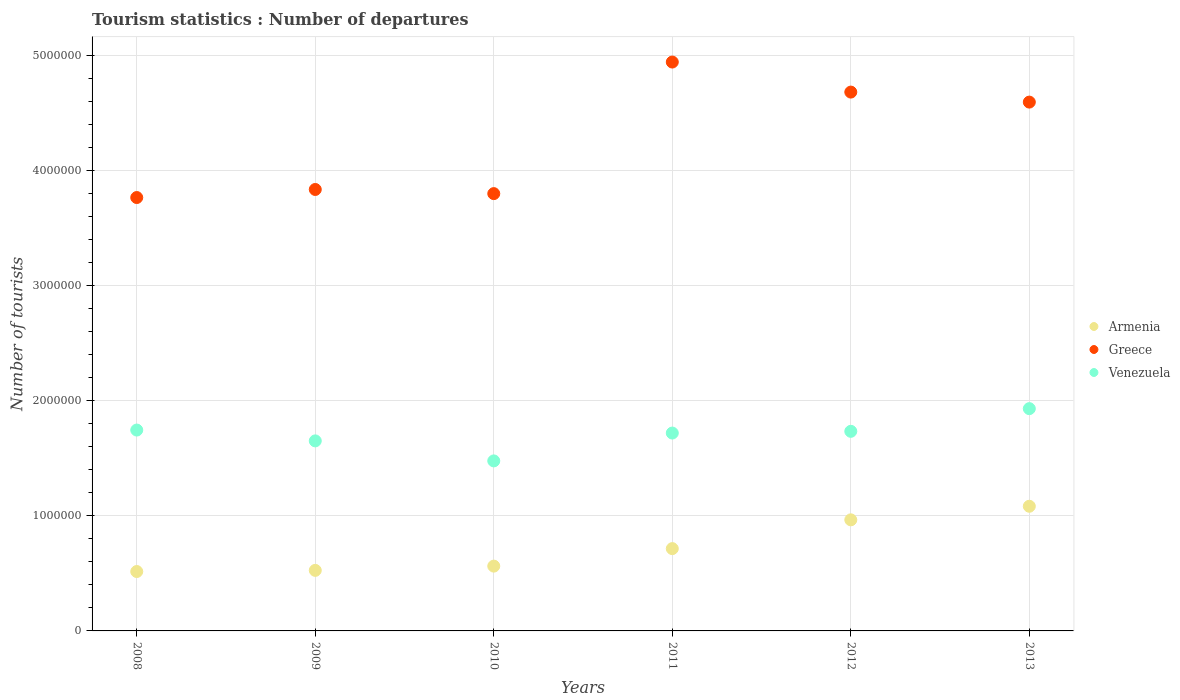How many different coloured dotlines are there?
Provide a short and direct response. 3. Is the number of dotlines equal to the number of legend labels?
Offer a terse response. Yes. What is the number of tourist departures in Armenia in 2011?
Provide a succinct answer. 7.15e+05. Across all years, what is the maximum number of tourist departures in Greece?
Give a very brief answer. 4.94e+06. Across all years, what is the minimum number of tourist departures in Armenia?
Your answer should be compact. 5.16e+05. In which year was the number of tourist departures in Armenia maximum?
Give a very brief answer. 2013. What is the total number of tourist departures in Armenia in the graph?
Your answer should be very brief. 4.37e+06. What is the difference between the number of tourist departures in Greece in 2009 and that in 2010?
Provide a succinct answer. 3.60e+04. What is the difference between the number of tourist departures in Venezuela in 2011 and the number of tourist departures in Armenia in 2009?
Your response must be concise. 1.19e+06. What is the average number of tourist departures in Greece per year?
Give a very brief answer. 4.27e+06. In the year 2010, what is the difference between the number of tourist departures in Armenia and number of tourist departures in Greece?
Offer a terse response. -3.24e+06. In how many years, is the number of tourist departures in Greece greater than 4200000?
Provide a short and direct response. 3. What is the ratio of the number of tourist departures in Venezuela in 2010 to that in 2011?
Make the answer very short. 0.86. Is the number of tourist departures in Armenia in 2012 less than that in 2013?
Ensure brevity in your answer.  Yes. What is the difference between the highest and the second highest number of tourist departures in Armenia?
Give a very brief answer. 1.18e+05. What is the difference between the highest and the lowest number of tourist departures in Venezuela?
Offer a very short reply. 4.54e+05. Is it the case that in every year, the sum of the number of tourist departures in Venezuela and number of tourist departures in Armenia  is greater than the number of tourist departures in Greece?
Offer a terse response. No. Does the graph contain any zero values?
Your answer should be very brief. No. Does the graph contain grids?
Make the answer very short. Yes. Where does the legend appear in the graph?
Provide a succinct answer. Center right. What is the title of the graph?
Offer a terse response. Tourism statistics : Number of departures. What is the label or title of the X-axis?
Your answer should be compact. Years. What is the label or title of the Y-axis?
Make the answer very short. Number of tourists. What is the Number of tourists of Armenia in 2008?
Keep it short and to the point. 5.16e+05. What is the Number of tourists of Greece in 2008?
Ensure brevity in your answer.  3.76e+06. What is the Number of tourists in Venezuela in 2008?
Offer a terse response. 1.74e+06. What is the Number of tourists of Armenia in 2009?
Make the answer very short. 5.26e+05. What is the Number of tourists of Greece in 2009?
Give a very brief answer. 3.84e+06. What is the Number of tourists of Venezuela in 2009?
Provide a succinct answer. 1.65e+06. What is the Number of tourists of Armenia in 2010?
Make the answer very short. 5.63e+05. What is the Number of tourists in Greece in 2010?
Offer a very short reply. 3.80e+06. What is the Number of tourists of Venezuela in 2010?
Offer a very short reply. 1.48e+06. What is the Number of tourists of Armenia in 2011?
Offer a very short reply. 7.15e+05. What is the Number of tourists of Greece in 2011?
Your answer should be very brief. 4.94e+06. What is the Number of tourists of Venezuela in 2011?
Your response must be concise. 1.72e+06. What is the Number of tourists of Armenia in 2012?
Provide a succinct answer. 9.65e+05. What is the Number of tourists in Greece in 2012?
Make the answer very short. 4.68e+06. What is the Number of tourists in Venezuela in 2012?
Keep it short and to the point. 1.73e+06. What is the Number of tourists of Armenia in 2013?
Ensure brevity in your answer.  1.08e+06. What is the Number of tourists of Greece in 2013?
Provide a short and direct response. 4.59e+06. What is the Number of tourists in Venezuela in 2013?
Your answer should be very brief. 1.93e+06. Across all years, what is the maximum Number of tourists of Armenia?
Give a very brief answer. 1.08e+06. Across all years, what is the maximum Number of tourists of Greece?
Your response must be concise. 4.94e+06. Across all years, what is the maximum Number of tourists in Venezuela?
Provide a succinct answer. 1.93e+06. Across all years, what is the minimum Number of tourists of Armenia?
Your answer should be compact. 5.16e+05. Across all years, what is the minimum Number of tourists in Greece?
Ensure brevity in your answer.  3.76e+06. Across all years, what is the minimum Number of tourists in Venezuela?
Keep it short and to the point. 1.48e+06. What is the total Number of tourists in Armenia in the graph?
Make the answer very short. 4.37e+06. What is the total Number of tourists in Greece in the graph?
Offer a terse response. 2.56e+07. What is the total Number of tourists in Venezuela in the graph?
Your response must be concise. 1.03e+07. What is the difference between the Number of tourists in Armenia in 2008 and that in 2009?
Offer a terse response. -10000. What is the difference between the Number of tourists of Venezuela in 2008 and that in 2009?
Your answer should be very brief. 9.40e+04. What is the difference between the Number of tourists in Armenia in 2008 and that in 2010?
Give a very brief answer. -4.70e+04. What is the difference between the Number of tourists of Greece in 2008 and that in 2010?
Offer a terse response. -3.40e+04. What is the difference between the Number of tourists in Venezuela in 2008 and that in 2010?
Ensure brevity in your answer.  2.68e+05. What is the difference between the Number of tourists in Armenia in 2008 and that in 2011?
Keep it short and to the point. -1.99e+05. What is the difference between the Number of tourists in Greece in 2008 and that in 2011?
Ensure brevity in your answer.  -1.18e+06. What is the difference between the Number of tourists of Venezuela in 2008 and that in 2011?
Keep it short and to the point. 2.60e+04. What is the difference between the Number of tourists of Armenia in 2008 and that in 2012?
Make the answer very short. -4.49e+05. What is the difference between the Number of tourists of Greece in 2008 and that in 2012?
Your answer should be very brief. -9.16e+05. What is the difference between the Number of tourists in Venezuela in 2008 and that in 2012?
Your answer should be very brief. 1.10e+04. What is the difference between the Number of tourists in Armenia in 2008 and that in 2013?
Your answer should be compact. -5.67e+05. What is the difference between the Number of tourists in Greece in 2008 and that in 2013?
Your answer should be very brief. -8.29e+05. What is the difference between the Number of tourists in Venezuela in 2008 and that in 2013?
Give a very brief answer. -1.86e+05. What is the difference between the Number of tourists in Armenia in 2009 and that in 2010?
Your answer should be compact. -3.70e+04. What is the difference between the Number of tourists in Greece in 2009 and that in 2010?
Your answer should be very brief. 3.60e+04. What is the difference between the Number of tourists of Venezuela in 2009 and that in 2010?
Provide a succinct answer. 1.74e+05. What is the difference between the Number of tourists of Armenia in 2009 and that in 2011?
Make the answer very short. -1.89e+05. What is the difference between the Number of tourists of Greece in 2009 and that in 2011?
Your answer should be very brief. -1.11e+06. What is the difference between the Number of tourists of Venezuela in 2009 and that in 2011?
Give a very brief answer. -6.80e+04. What is the difference between the Number of tourists of Armenia in 2009 and that in 2012?
Your response must be concise. -4.39e+05. What is the difference between the Number of tourists of Greece in 2009 and that in 2012?
Your answer should be compact. -8.46e+05. What is the difference between the Number of tourists of Venezuela in 2009 and that in 2012?
Make the answer very short. -8.30e+04. What is the difference between the Number of tourists of Armenia in 2009 and that in 2013?
Provide a short and direct response. -5.57e+05. What is the difference between the Number of tourists in Greece in 2009 and that in 2013?
Your answer should be very brief. -7.59e+05. What is the difference between the Number of tourists in Venezuela in 2009 and that in 2013?
Provide a short and direct response. -2.80e+05. What is the difference between the Number of tourists of Armenia in 2010 and that in 2011?
Provide a short and direct response. -1.52e+05. What is the difference between the Number of tourists of Greece in 2010 and that in 2011?
Make the answer very short. -1.14e+06. What is the difference between the Number of tourists of Venezuela in 2010 and that in 2011?
Provide a short and direct response. -2.42e+05. What is the difference between the Number of tourists in Armenia in 2010 and that in 2012?
Make the answer very short. -4.02e+05. What is the difference between the Number of tourists of Greece in 2010 and that in 2012?
Your answer should be very brief. -8.82e+05. What is the difference between the Number of tourists of Venezuela in 2010 and that in 2012?
Provide a succinct answer. -2.57e+05. What is the difference between the Number of tourists in Armenia in 2010 and that in 2013?
Provide a short and direct response. -5.20e+05. What is the difference between the Number of tourists in Greece in 2010 and that in 2013?
Keep it short and to the point. -7.95e+05. What is the difference between the Number of tourists of Venezuela in 2010 and that in 2013?
Provide a short and direct response. -4.54e+05. What is the difference between the Number of tourists in Greece in 2011 and that in 2012?
Give a very brief answer. 2.61e+05. What is the difference between the Number of tourists in Venezuela in 2011 and that in 2012?
Your answer should be compact. -1.50e+04. What is the difference between the Number of tourists in Armenia in 2011 and that in 2013?
Provide a succinct answer. -3.68e+05. What is the difference between the Number of tourists in Greece in 2011 and that in 2013?
Your answer should be compact. 3.48e+05. What is the difference between the Number of tourists of Venezuela in 2011 and that in 2013?
Your answer should be very brief. -2.12e+05. What is the difference between the Number of tourists of Armenia in 2012 and that in 2013?
Offer a terse response. -1.18e+05. What is the difference between the Number of tourists in Greece in 2012 and that in 2013?
Your answer should be compact. 8.70e+04. What is the difference between the Number of tourists of Venezuela in 2012 and that in 2013?
Your answer should be compact. -1.97e+05. What is the difference between the Number of tourists in Armenia in 2008 and the Number of tourists in Greece in 2009?
Your response must be concise. -3.32e+06. What is the difference between the Number of tourists in Armenia in 2008 and the Number of tourists in Venezuela in 2009?
Give a very brief answer. -1.14e+06. What is the difference between the Number of tourists of Greece in 2008 and the Number of tourists of Venezuela in 2009?
Provide a succinct answer. 2.11e+06. What is the difference between the Number of tourists in Armenia in 2008 and the Number of tourists in Greece in 2010?
Keep it short and to the point. -3.28e+06. What is the difference between the Number of tourists of Armenia in 2008 and the Number of tourists of Venezuela in 2010?
Make the answer very short. -9.61e+05. What is the difference between the Number of tourists in Greece in 2008 and the Number of tourists in Venezuela in 2010?
Your response must be concise. 2.29e+06. What is the difference between the Number of tourists in Armenia in 2008 and the Number of tourists in Greece in 2011?
Keep it short and to the point. -4.43e+06. What is the difference between the Number of tourists of Armenia in 2008 and the Number of tourists of Venezuela in 2011?
Give a very brief answer. -1.20e+06. What is the difference between the Number of tourists in Greece in 2008 and the Number of tourists in Venezuela in 2011?
Your response must be concise. 2.05e+06. What is the difference between the Number of tourists of Armenia in 2008 and the Number of tourists of Greece in 2012?
Your response must be concise. -4.16e+06. What is the difference between the Number of tourists of Armenia in 2008 and the Number of tourists of Venezuela in 2012?
Provide a short and direct response. -1.22e+06. What is the difference between the Number of tourists in Greece in 2008 and the Number of tourists in Venezuela in 2012?
Offer a very short reply. 2.03e+06. What is the difference between the Number of tourists of Armenia in 2008 and the Number of tourists of Greece in 2013?
Your answer should be very brief. -4.08e+06. What is the difference between the Number of tourists of Armenia in 2008 and the Number of tourists of Venezuela in 2013?
Your answer should be very brief. -1.42e+06. What is the difference between the Number of tourists in Greece in 2008 and the Number of tourists in Venezuela in 2013?
Ensure brevity in your answer.  1.83e+06. What is the difference between the Number of tourists of Armenia in 2009 and the Number of tourists of Greece in 2010?
Provide a short and direct response. -3.27e+06. What is the difference between the Number of tourists in Armenia in 2009 and the Number of tourists in Venezuela in 2010?
Offer a terse response. -9.51e+05. What is the difference between the Number of tourists of Greece in 2009 and the Number of tourists of Venezuela in 2010?
Your response must be concise. 2.36e+06. What is the difference between the Number of tourists in Armenia in 2009 and the Number of tourists in Greece in 2011?
Your answer should be very brief. -4.42e+06. What is the difference between the Number of tourists in Armenia in 2009 and the Number of tourists in Venezuela in 2011?
Ensure brevity in your answer.  -1.19e+06. What is the difference between the Number of tourists in Greece in 2009 and the Number of tourists in Venezuela in 2011?
Your answer should be very brief. 2.12e+06. What is the difference between the Number of tourists of Armenia in 2009 and the Number of tourists of Greece in 2012?
Your response must be concise. -4.16e+06. What is the difference between the Number of tourists of Armenia in 2009 and the Number of tourists of Venezuela in 2012?
Keep it short and to the point. -1.21e+06. What is the difference between the Number of tourists of Greece in 2009 and the Number of tourists of Venezuela in 2012?
Your answer should be compact. 2.10e+06. What is the difference between the Number of tourists in Armenia in 2009 and the Number of tourists in Greece in 2013?
Give a very brief answer. -4.07e+06. What is the difference between the Number of tourists of Armenia in 2009 and the Number of tourists of Venezuela in 2013?
Provide a short and direct response. -1.40e+06. What is the difference between the Number of tourists in Greece in 2009 and the Number of tourists in Venezuela in 2013?
Offer a very short reply. 1.90e+06. What is the difference between the Number of tourists in Armenia in 2010 and the Number of tourists in Greece in 2011?
Provide a short and direct response. -4.38e+06. What is the difference between the Number of tourists of Armenia in 2010 and the Number of tourists of Venezuela in 2011?
Give a very brief answer. -1.16e+06. What is the difference between the Number of tourists of Greece in 2010 and the Number of tourists of Venezuela in 2011?
Make the answer very short. 2.08e+06. What is the difference between the Number of tourists of Armenia in 2010 and the Number of tourists of Greece in 2012?
Provide a succinct answer. -4.12e+06. What is the difference between the Number of tourists in Armenia in 2010 and the Number of tourists in Venezuela in 2012?
Provide a succinct answer. -1.17e+06. What is the difference between the Number of tourists of Greece in 2010 and the Number of tourists of Venezuela in 2012?
Your response must be concise. 2.06e+06. What is the difference between the Number of tourists in Armenia in 2010 and the Number of tourists in Greece in 2013?
Provide a succinct answer. -4.03e+06. What is the difference between the Number of tourists in Armenia in 2010 and the Number of tourists in Venezuela in 2013?
Provide a succinct answer. -1.37e+06. What is the difference between the Number of tourists of Greece in 2010 and the Number of tourists of Venezuela in 2013?
Your response must be concise. 1.87e+06. What is the difference between the Number of tourists in Armenia in 2011 and the Number of tourists in Greece in 2012?
Keep it short and to the point. -3.97e+06. What is the difference between the Number of tourists in Armenia in 2011 and the Number of tourists in Venezuela in 2012?
Your answer should be compact. -1.02e+06. What is the difference between the Number of tourists of Greece in 2011 and the Number of tourists of Venezuela in 2012?
Make the answer very short. 3.21e+06. What is the difference between the Number of tourists of Armenia in 2011 and the Number of tourists of Greece in 2013?
Offer a very short reply. -3.88e+06. What is the difference between the Number of tourists in Armenia in 2011 and the Number of tourists in Venezuela in 2013?
Provide a short and direct response. -1.22e+06. What is the difference between the Number of tourists of Greece in 2011 and the Number of tourists of Venezuela in 2013?
Provide a succinct answer. 3.01e+06. What is the difference between the Number of tourists of Armenia in 2012 and the Number of tourists of Greece in 2013?
Offer a very short reply. -3.63e+06. What is the difference between the Number of tourists in Armenia in 2012 and the Number of tourists in Venezuela in 2013?
Give a very brief answer. -9.66e+05. What is the difference between the Number of tourists of Greece in 2012 and the Number of tourists of Venezuela in 2013?
Offer a terse response. 2.75e+06. What is the average Number of tourists of Armenia per year?
Your response must be concise. 7.28e+05. What is the average Number of tourists in Greece per year?
Give a very brief answer. 4.27e+06. What is the average Number of tourists in Venezuela per year?
Ensure brevity in your answer.  1.71e+06. In the year 2008, what is the difference between the Number of tourists in Armenia and Number of tourists in Greece?
Make the answer very short. -3.25e+06. In the year 2008, what is the difference between the Number of tourists of Armenia and Number of tourists of Venezuela?
Keep it short and to the point. -1.23e+06. In the year 2008, what is the difference between the Number of tourists of Greece and Number of tourists of Venezuela?
Give a very brief answer. 2.02e+06. In the year 2009, what is the difference between the Number of tourists in Armenia and Number of tourists in Greece?
Provide a succinct answer. -3.31e+06. In the year 2009, what is the difference between the Number of tourists in Armenia and Number of tourists in Venezuela?
Keep it short and to the point. -1.12e+06. In the year 2009, what is the difference between the Number of tourists in Greece and Number of tourists in Venezuela?
Ensure brevity in your answer.  2.18e+06. In the year 2010, what is the difference between the Number of tourists of Armenia and Number of tourists of Greece?
Make the answer very short. -3.24e+06. In the year 2010, what is the difference between the Number of tourists in Armenia and Number of tourists in Venezuela?
Your answer should be compact. -9.14e+05. In the year 2010, what is the difference between the Number of tourists in Greece and Number of tourists in Venezuela?
Your response must be concise. 2.32e+06. In the year 2011, what is the difference between the Number of tourists of Armenia and Number of tourists of Greece?
Ensure brevity in your answer.  -4.23e+06. In the year 2011, what is the difference between the Number of tourists in Armenia and Number of tourists in Venezuela?
Keep it short and to the point. -1.00e+06. In the year 2011, what is the difference between the Number of tourists of Greece and Number of tourists of Venezuela?
Offer a very short reply. 3.22e+06. In the year 2012, what is the difference between the Number of tourists of Armenia and Number of tourists of Greece?
Ensure brevity in your answer.  -3.72e+06. In the year 2012, what is the difference between the Number of tourists in Armenia and Number of tourists in Venezuela?
Your answer should be very brief. -7.69e+05. In the year 2012, what is the difference between the Number of tourists of Greece and Number of tourists of Venezuela?
Your answer should be compact. 2.95e+06. In the year 2013, what is the difference between the Number of tourists in Armenia and Number of tourists in Greece?
Your answer should be very brief. -3.51e+06. In the year 2013, what is the difference between the Number of tourists of Armenia and Number of tourists of Venezuela?
Your answer should be compact. -8.48e+05. In the year 2013, what is the difference between the Number of tourists in Greece and Number of tourists in Venezuela?
Provide a short and direct response. 2.66e+06. What is the ratio of the Number of tourists in Armenia in 2008 to that in 2009?
Offer a terse response. 0.98. What is the ratio of the Number of tourists of Greece in 2008 to that in 2009?
Your answer should be compact. 0.98. What is the ratio of the Number of tourists of Venezuela in 2008 to that in 2009?
Ensure brevity in your answer.  1.06. What is the ratio of the Number of tourists in Armenia in 2008 to that in 2010?
Give a very brief answer. 0.92. What is the ratio of the Number of tourists of Greece in 2008 to that in 2010?
Offer a terse response. 0.99. What is the ratio of the Number of tourists of Venezuela in 2008 to that in 2010?
Offer a very short reply. 1.18. What is the ratio of the Number of tourists in Armenia in 2008 to that in 2011?
Give a very brief answer. 0.72. What is the ratio of the Number of tourists in Greece in 2008 to that in 2011?
Keep it short and to the point. 0.76. What is the ratio of the Number of tourists of Venezuela in 2008 to that in 2011?
Give a very brief answer. 1.02. What is the ratio of the Number of tourists in Armenia in 2008 to that in 2012?
Provide a short and direct response. 0.53. What is the ratio of the Number of tourists of Greece in 2008 to that in 2012?
Make the answer very short. 0.8. What is the ratio of the Number of tourists of Armenia in 2008 to that in 2013?
Offer a very short reply. 0.48. What is the ratio of the Number of tourists in Greece in 2008 to that in 2013?
Give a very brief answer. 0.82. What is the ratio of the Number of tourists of Venezuela in 2008 to that in 2013?
Keep it short and to the point. 0.9. What is the ratio of the Number of tourists in Armenia in 2009 to that in 2010?
Your answer should be compact. 0.93. What is the ratio of the Number of tourists in Greece in 2009 to that in 2010?
Your response must be concise. 1.01. What is the ratio of the Number of tourists in Venezuela in 2009 to that in 2010?
Provide a succinct answer. 1.12. What is the ratio of the Number of tourists in Armenia in 2009 to that in 2011?
Offer a terse response. 0.74. What is the ratio of the Number of tourists of Greece in 2009 to that in 2011?
Your answer should be very brief. 0.78. What is the ratio of the Number of tourists of Venezuela in 2009 to that in 2011?
Provide a succinct answer. 0.96. What is the ratio of the Number of tourists of Armenia in 2009 to that in 2012?
Your response must be concise. 0.55. What is the ratio of the Number of tourists of Greece in 2009 to that in 2012?
Offer a very short reply. 0.82. What is the ratio of the Number of tourists in Venezuela in 2009 to that in 2012?
Ensure brevity in your answer.  0.95. What is the ratio of the Number of tourists in Armenia in 2009 to that in 2013?
Ensure brevity in your answer.  0.49. What is the ratio of the Number of tourists in Greece in 2009 to that in 2013?
Provide a short and direct response. 0.83. What is the ratio of the Number of tourists of Venezuela in 2009 to that in 2013?
Keep it short and to the point. 0.85. What is the ratio of the Number of tourists of Armenia in 2010 to that in 2011?
Give a very brief answer. 0.79. What is the ratio of the Number of tourists of Greece in 2010 to that in 2011?
Your answer should be compact. 0.77. What is the ratio of the Number of tourists in Venezuela in 2010 to that in 2011?
Keep it short and to the point. 0.86. What is the ratio of the Number of tourists of Armenia in 2010 to that in 2012?
Keep it short and to the point. 0.58. What is the ratio of the Number of tourists in Greece in 2010 to that in 2012?
Provide a short and direct response. 0.81. What is the ratio of the Number of tourists in Venezuela in 2010 to that in 2012?
Offer a very short reply. 0.85. What is the ratio of the Number of tourists in Armenia in 2010 to that in 2013?
Provide a succinct answer. 0.52. What is the ratio of the Number of tourists in Greece in 2010 to that in 2013?
Offer a terse response. 0.83. What is the ratio of the Number of tourists of Venezuela in 2010 to that in 2013?
Give a very brief answer. 0.76. What is the ratio of the Number of tourists in Armenia in 2011 to that in 2012?
Give a very brief answer. 0.74. What is the ratio of the Number of tourists of Greece in 2011 to that in 2012?
Ensure brevity in your answer.  1.06. What is the ratio of the Number of tourists of Venezuela in 2011 to that in 2012?
Your response must be concise. 0.99. What is the ratio of the Number of tourists of Armenia in 2011 to that in 2013?
Offer a very short reply. 0.66. What is the ratio of the Number of tourists in Greece in 2011 to that in 2013?
Provide a short and direct response. 1.08. What is the ratio of the Number of tourists in Venezuela in 2011 to that in 2013?
Give a very brief answer. 0.89. What is the ratio of the Number of tourists of Armenia in 2012 to that in 2013?
Keep it short and to the point. 0.89. What is the ratio of the Number of tourists of Greece in 2012 to that in 2013?
Your answer should be very brief. 1.02. What is the ratio of the Number of tourists in Venezuela in 2012 to that in 2013?
Your answer should be very brief. 0.9. What is the difference between the highest and the second highest Number of tourists of Armenia?
Provide a short and direct response. 1.18e+05. What is the difference between the highest and the second highest Number of tourists in Greece?
Your response must be concise. 2.61e+05. What is the difference between the highest and the second highest Number of tourists in Venezuela?
Your answer should be compact. 1.86e+05. What is the difference between the highest and the lowest Number of tourists of Armenia?
Provide a succinct answer. 5.67e+05. What is the difference between the highest and the lowest Number of tourists of Greece?
Provide a succinct answer. 1.18e+06. What is the difference between the highest and the lowest Number of tourists in Venezuela?
Your response must be concise. 4.54e+05. 